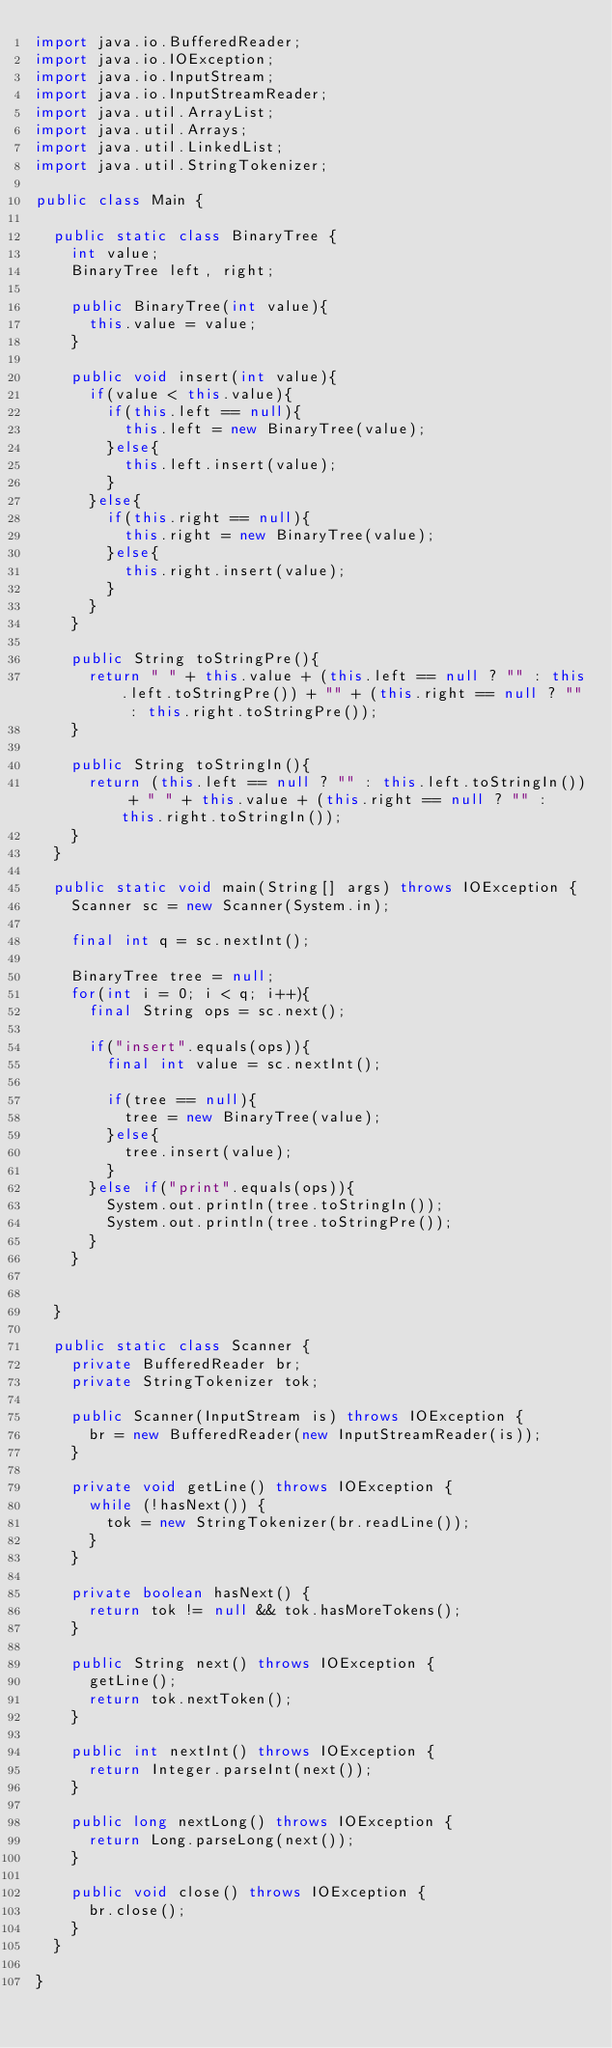<code> <loc_0><loc_0><loc_500><loc_500><_Java_>import java.io.BufferedReader;
import java.io.IOException;
import java.io.InputStream;
import java.io.InputStreamReader;
import java.util.ArrayList;
import java.util.Arrays;
import java.util.LinkedList;
import java.util.StringTokenizer;

public class Main {
	
	public static class BinaryTree {
		int value;
		BinaryTree left, right;
		
		public BinaryTree(int value){
			this.value = value;
		}
		
		public void insert(int value){
			if(value < this.value){
				if(this.left == null){
					this.left = new BinaryTree(value);
				}else{
					this.left.insert(value);
				}
			}else{
				if(this.right == null){
					this.right = new BinaryTree(value);
				}else{
					this.right.insert(value);
				}
			}
		}
		
		public String toStringPre(){
			return " " + this.value + (this.left == null ? "" : this.left.toStringPre()) + "" + (this.right == null ? "" : this.right.toStringPre());
		}
		
		public String toStringIn(){
			return (this.left == null ? "" : this.left.toStringIn()) + " " + this.value + (this.right == null ? "" : this.right.toStringIn());
		}
	}
	
	public static void main(String[] args) throws IOException {
		Scanner sc = new Scanner(System.in);
		
		final int q = sc.nextInt();
		
		BinaryTree tree = null;
		for(int i = 0; i < q; i++){
			final String ops = sc.next();
			
			if("insert".equals(ops)){
				final int value = sc.nextInt();
				
				if(tree == null){
					tree = new BinaryTree(value);
				}else{
					tree.insert(value);
				}
			}else if("print".equals(ops)){
				System.out.println(tree.toStringIn());
				System.out.println(tree.toStringPre());
			}
		}
		
		
	}

	public static class Scanner {
		private BufferedReader br;
		private StringTokenizer tok;

		public Scanner(InputStream is) throws IOException {
			br = new BufferedReader(new InputStreamReader(is));
		}

		private void getLine() throws IOException {
			while (!hasNext()) {
				tok = new StringTokenizer(br.readLine());
			}
		}

		private boolean hasNext() {
			return tok != null && tok.hasMoreTokens();
		}

		public String next() throws IOException {
			getLine();
			return tok.nextToken();
		}

		public int nextInt() throws IOException {
			return Integer.parseInt(next());
		}

		public long nextLong() throws IOException {
			return Long.parseLong(next());
		}

		public void close() throws IOException {
			br.close();
		}
	}

}</code> 